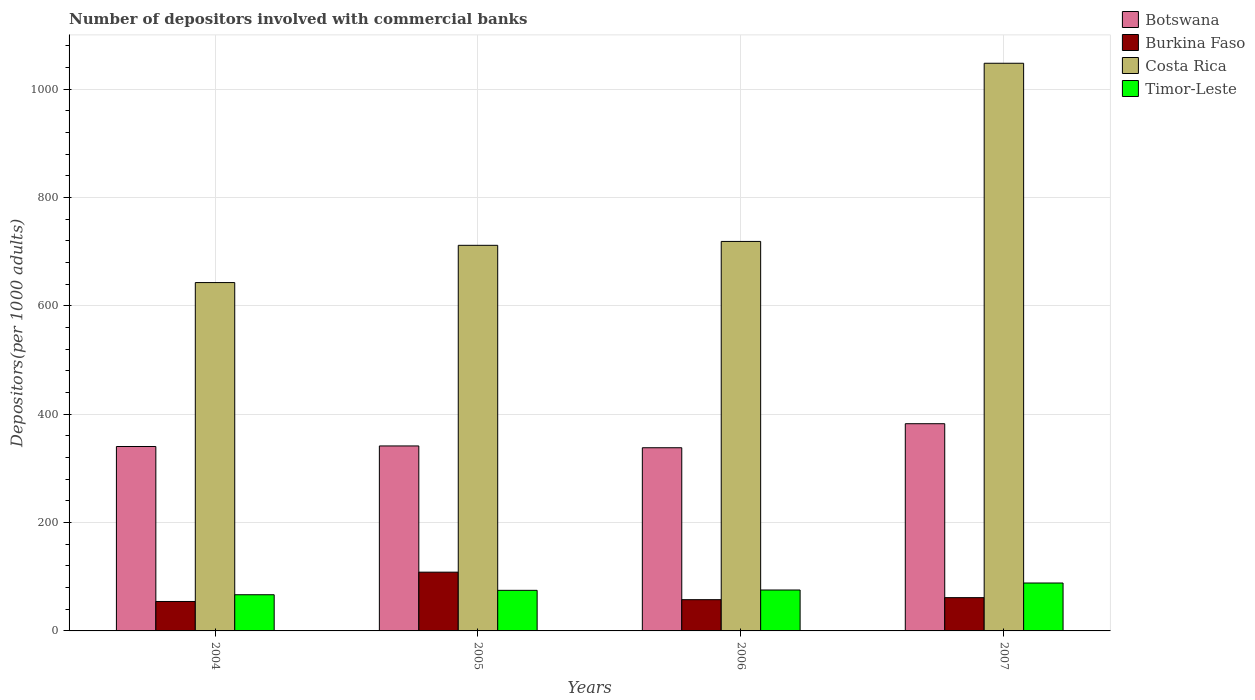How many different coloured bars are there?
Provide a succinct answer. 4. How many groups of bars are there?
Your response must be concise. 4. Are the number of bars per tick equal to the number of legend labels?
Offer a terse response. Yes. Are the number of bars on each tick of the X-axis equal?
Offer a very short reply. Yes. How many bars are there on the 4th tick from the right?
Offer a very short reply. 4. In how many cases, is the number of bars for a given year not equal to the number of legend labels?
Your answer should be compact. 0. What is the number of depositors involved with commercial banks in Costa Rica in 2005?
Ensure brevity in your answer.  711.68. Across all years, what is the maximum number of depositors involved with commercial banks in Timor-Leste?
Your answer should be compact. 88.44. Across all years, what is the minimum number of depositors involved with commercial banks in Botswana?
Ensure brevity in your answer.  338.08. What is the total number of depositors involved with commercial banks in Burkina Faso in the graph?
Offer a terse response. 281.87. What is the difference between the number of depositors involved with commercial banks in Timor-Leste in 2004 and that in 2006?
Your response must be concise. -8.76. What is the difference between the number of depositors involved with commercial banks in Timor-Leste in 2005 and the number of depositors involved with commercial banks in Botswana in 2004?
Offer a terse response. -265.45. What is the average number of depositors involved with commercial banks in Costa Rica per year?
Your response must be concise. 780.3. In the year 2007, what is the difference between the number of depositors involved with commercial banks in Costa Rica and number of depositors involved with commercial banks in Botswana?
Ensure brevity in your answer.  665.28. In how many years, is the number of depositors involved with commercial banks in Timor-Leste greater than 400?
Provide a succinct answer. 0. What is the ratio of the number of depositors involved with commercial banks in Costa Rica in 2004 to that in 2007?
Make the answer very short. 0.61. Is the difference between the number of depositors involved with commercial banks in Costa Rica in 2006 and 2007 greater than the difference between the number of depositors involved with commercial banks in Botswana in 2006 and 2007?
Provide a succinct answer. No. What is the difference between the highest and the second highest number of depositors involved with commercial banks in Burkina Faso?
Your answer should be very brief. 47.04. What is the difference between the highest and the lowest number of depositors involved with commercial banks in Costa Rica?
Your answer should be compact. 404.79. What does the 2nd bar from the left in 2004 represents?
Offer a terse response. Burkina Faso. What does the 4th bar from the right in 2006 represents?
Offer a very short reply. Botswana. Is it the case that in every year, the sum of the number of depositors involved with commercial banks in Timor-Leste and number of depositors involved with commercial banks in Burkina Faso is greater than the number of depositors involved with commercial banks in Botswana?
Keep it short and to the point. No. How many bars are there?
Your answer should be compact. 16. Are the values on the major ticks of Y-axis written in scientific E-notation?
Provide a succinct answer. No. How many legend labels are there?
Offer a terse response. 4. How are the legend labels stacked?
Make the answer very short. Vertical. What is the title of the graph?
Ensure brevity in your answer.  Number of depositors involved with commercial banks. What is the label or title of the X-axis?
Provide a succinct answer. Years. What is the label or title of the Y-axis?
Offer a very short reply. Depositors(per 1000 adults). What is the Depositors(per 1000 adults) in Botswana in 2004?
Keep it short and to the point. 340.37. What is the Depositors(per 1000 adults) in Burkina Faso in 2004?
Provide a short and direct response. 54.35. What is the Depositors(per 1000 adults) of Costa Rica in 2004?
Offer a very short reply. 642.93. What is the Depositors(per 1000 adults) in Timor-Leste in 2004?
Ensure brevity in your answer.  66.76. What is the Depositors(per 1000 adults) of Botswana in 2005?
Offer a very short reply. 341.4. What is the Depositors(per 1000 adults) in Burkina Faso in 2005?
Keep it short and to the point. 108.45. What is the Depositors(per 1000 adults) of Costa Rica in 2005?
Provide a short and direct response. 711.68. What is the Depositors(per 1000 adults) in Timor-Leste in 2005?
Ensure brevity in your answer.  74.92. What is the Depositors(per 1000 adults) in Botswana in 2006?
Offer a very short reply. 338.08. What is the Depositors(per 1000 adults) in Burkina Faso in 2006?
Your answer should be very brief. 57.67. What is the Depositors(per 1000 adults) of Costa Rica in 2006?
Your response must be concise. 718.87. What is the Depositors(per 1000 adults) in Timor-Leste in 2006?
Your answer should be very brief. 75.52. What is the Depositors(per 1000 adults) in Botswana in 2007?
Make the answer very short. 382.43. What is the Depositors(per 1000 adults) in Burkina Faso in 2007?
Keep it short and to the point. 61.41. What is the Depositors(per 1000 adults) in Costa Rica in 2007?
Your answer should be compact. 1047.71. What is the Depositors(per 1000 adults) in Timor-Leste in 2007?
Your answer should be very brief. 88.44. Across all years, what is the maximum Depositors(per 1000 adults) in Botswana?
Make the answer very short. 382.43. Across all years, what is the maximum Depositors(per 1000 adults) of Burkina Faso?
Provide a short and direct response. 108.45. Across all years, what is the maximum Depositors(per 1000 adults) of Costa Rica?
Provide a succinct answer. 1047.71. Across all years, what is the maximum Depositors(per 1000 adults) in Timor-Leste?
Provide a succinct answer. 88.44. Across all years, what is the minimum Depositors(per 1000 adults) in Botswana?
Give a very brief answer. 338.08. Across all years, what is the minimum Depositors(per 1000 adults) of Burkina Faso?
Provide a succinct answer. 54.35. Across all years, what is the minimum Depositors(per 1000 adults) of Costa Rica?
Your answer should be compact. 642.93. Across all years, what is the minimum Depositors(per 1000 adults) in Timor-Leste?
Offer a terse response. 66.76. What is the total Depositors(per 1000 adults) of Botswana in the graph?
Provide a short and direct response. 1402.28. What is the total Depositors(per 1000 adults) in Burkina Faso in the graph?
Your answer should be compact. 281.87. What is the total Depositors(per 1000 adults) in Costa Rica in the graph?
Your answer should be very brief. 3121.18. What is the total Depositors(per 1000 adults) of Timor-Leste in the graph?
Make the answer very short. 305.65. What is the difference between the Depositors(per 1000 adults) in Botswana in 2004 and that in 2005?
Your response must be concise. -1.03. What is the difference between the Depositors(per 1000 adults) in Burkina Faso in 2004 and that in 2005?
Your response must be concise. -54.1. What is the difference between the Depositors(per 1000 adults) of Costa Rica in 2004 and that in 2005?
Your answer should be compact. -68.75. What is the difference between the Depositors(per 1000 adults) of Timor-Leste in 2004 and that in 2005?
Your answer should be compact. -8.16. What is the difference between the Depositors(per 1000 adults) in Botswana in 2004 and that in 2006?
Ensure brevity in your answer.  2.3. What is the difference between the Depositors(per 1000 adults) of Burkina Faso in 2004 and that in 2006?
Keep it short and to the point. -3.32. What is the difference between the Depositors(per 1000 adults) in Costa Rica in 2004 and that in 2006?
Your response must be concise. -75.94. What is the difference between the Depositors(per 1000 adults) of Timor-Leste in 2004 and that in 2006?
Your answer should be very brief. -8.76. What is the difference between the Depositors(per 1000 adults) in Botswana in 2004 and that in 2007?
Provide a succinct answer. -42.06. What is the difference between the Depositors(per 1000 adults) in Burkina Faso in 2004 and that in 2007?
Give a very brief answer. -7.06. What is the difference between the Depositors(per 1000 adults) in Costa Rica in 2004 and that in 2007?
Ensure brevity in your answer.  -404.79. What is the difference between the Depositors(per 1000 adults) in Timor-Leste in 2004 and that in 2007?
Offer a terse response. -21.68. What is the difference between the Depositors(per 1000 adults) in Botswana in 2005 and that in 2006?
Keep it short and to the point. 3.33. What is the difference between the Depositors(per 1000 adults) of Burkina Faso in 2005 and that in 2006?
Provide a short and direct response. 50.78. What is the difference between the Depositors(per 1000 adults) of Costa Rica in 2005 and that in 2006?
Your answer should be compact. -7.19. What is the difference between the Depositors(per 1000 adults) of Timor-Leste in 2005 and that in 2006?
Provide a succinct answer. -0.61. What is the difference between the Depositors(per 1000 adults) of Botswana in 2005 and that in 2007?
Ensure brevity in your answer.  -41.03. What is the difference between the Depositors(per 1000 adults) in Burkina Faso in 2005 and that in 2007?
Keep it short and to the point. 47.04. What is the difference between the Depositors(per 1000 adults) in Costa Rica in 2005 and that in 2007?
Make the answer very short. -336.04. What is the difference between the Depositors(per 1000 adults) in Timor-Leste in 2005 and that in 2007?
Offer a terse response. -13.52. What is the difference between the Depositors(per 1000 adults) of Botswana in 2006 and that in 2007?
Give a very brief answer. -44.36. What is the difference between the Depositors(per 1000 adults) of Burkina Faso in 2006 and that in 2007?
Make the answer very short. -3.74. What is the difference between the Depositors(per 1000 adults) in Costa Rica in 2006 and that in 2007?
Provide a short and direct response. -328.85. What is the difference between the Depositors(per 1000 adults) in Timor-Leste in 2006 and that in 2007?
Give a very brief answer. -12.92. What is the difference between the Depositors(per 1000 adults) of Botswana in 2004 and the Depositors(per 1000 adults) of Burkina Faso in 2005?
Offer a very short reply. 231.92. What is the difference between the Depositors(per 1000 adults) in Botswana in 2004 and the Depositors(per 1000 adults) in Costa Rica in 2005?
Keep it short and to the point. -371.3. What is the difference between the Depositors(per 1000 adults) of Botswana in 2004 and the Depositors(per 1000 adults) of Timor-Leste in 2005?
Ensure brevity in your answer.  265.45. What is the difference between the Depositors(per 1000 adults) in Burkina Faso in 2004 and the Depositors(per 1000 adults) in Costa Rica in 2005?
Provide a succinct answer. -657.33. What is the difference between the Depositors(per 1000 adults) in Burkina Faso in 2004 and the Depositors(per 1000 adults) in Timor-Leste in 2005?
Ensure brevity in your answer.  -20.57. What is the difference between the Depositors(per 1000 adults) of Costa Rica in 2004 and the Depositors(per 1000 adults) of Timor-Leste in 2005?
Your answer should be very brief. 568.01. What is the difference between the Depositors(per 1000 adults) of Botswana in 2004 and the Depositors(per 1000 adults) of Burkina Faso in 2006?
Your answer should be very brief. 282.71. What is the difference between the Depositors(per 1000 adults) in Botswana in 2004 and the Depositors(per 1000 adults) in Costa Rica in 2006?
Offer a very short reply. -378.49. What is the difference between the Depositors(per 1000 adults) in Botswana in 2004 and the Depositors(per 1000 adults) in Timor-Leste in 2006?
Your response must be concise. 264.85. What is the difference between the Depositors(per 1000 adults) of Burkina Faso in 2004 and the Depositors(per 1000 adults) of Costa Rica in 2006?
Provide a succinct answer. -664.52. What is the difference between the Depositors(per 1000 adults) of Burkina Faso in 2004 and the Depositors(per 1000 adults) of Timor-Leste in 2006?
Provide a short and direct response. -21.18. What is the difference between the Depositors(per 1000 adults) in Costa Rica in 2004 and the Depositors(per 1000 adults) in Timor-Leste in 2006?
Offer a terse response. 567.4. What is the difference between the Depositors(per 1000 adults) in Botswana in 2004 and the Depositors(per 1000 adults) in Burkina Faso in 2007?
Ensure brevity in your answer.  278.96. What is the difference between the Depositors(per 1000 adults) of Botswana in 2004 and the Depositors(per 1000 adults) of Costa Rica in 2007?
Provide a succinct answer. -707.34. What is the difference between the Depositors(per 1000 adults) of Botswana in 2004 and the Depositors(per 1000 adults) of Timor-Leste in 2007?
Your answer should be very brief. 251.93. What is the difference between the Depositors(per 1000 adults) in Burkina Faso in 2004 and the Depositors(per 1000 adults) in Costa Rica in 2007?
Offer a terse response. -993.37. What is the difference between the Depositors(per 1000 adults) of Burkina Faso in 2004 and the Depositors(per 1000 adults) of Timor-Leste in 2007?
Provide a short and direct response. -34.1. What is the difference between the Depositors(per 1000 adults) in Costa Rica in 2004 and the Depositors(per 1000 adults) in Timor-Leste in 2007?
Your answer should be very brief. 554.48. What is the difference between the Depositors(per 1000 adults) of Botswana in 2005 and the Depositors(per 1000 adults) of Burkina Faso in 2006?
Your answer should be very brief. 283.74. What is the difference between the Depositors(per 1000 adults) of Botswana in 2005 and the Depositors(per 1000 adults) of Costa Rica in 2006?
Give a very brief answer. -377.46. What is the difference between the Depositors(per 1000 adults) of Botswana in 2005 and the Depositors(per 1000 adults) of Timor-Leste in 2006?
Ensure brevity in your answer.  265.88. What is the difference between the Depositors(per 1000 adults) of Burkina Faso in 2005 and the Depositors(per 1000 adults) of Costa Rica in 2006?
Offer a terse response. -610.42. What is the difference between the Depositors(per 1000 adults) in Burkina Faso in 2005 and the Depositors(per 1000 adults) in Timor-Leste in 2006?
Ensure brevity in your answer.  32.92. What is the difference between the Depositors(per 1000 adults) of Costa Rica in 2005 and the Depositors(per 1000 adults) of Timor-Leste in 2006?
Offer a very short reply. 636.15. What is the difference between the Depositors(per 1000 adults) of Botswana in 2005 and the Depositors(per 1000 adults) of Burkina Faso in 2007?
Ensure brevity in your answer.  279.99. What is the difference between the Depositors(per 1000 adults) of Botswana in 2005 and the Depositors(per 1000 adults) of Costa Rica in 2007?
Offer a very short reply. -706.31. What is the difference between the Depositors(per 1000 adults) in Botswana in 2005 and the Depositors(per 1000 adults) in Timor-Leste in 2007?
Your answer should be compact. 252.96. What is the difference between the Depositors(per 1000 adults) in Burkina Faso in 2005 and the Depositors(per 1000 adults) in Costa Rica in 2007?
Your answer should be compact. -939.27. What is the difference between the Depositors(per 1000 adults) in Burkina Faso in 2005 and the Depositors(per 1000 adults) in Timor-Leste in 2007?
Offer a very short reply. 20. What is the difference between the Depositors(per 1000 adults) of Costa Rica in 2005 and the Depositors(per 1000 adults) of Timor-Leste in 2007?
Your answer should be compact. 623.23. What is the difference between the Depositors(per 1000 adults) of Botswana in 2006 and the Depositors(per 1000 adults) of Burkina Faso in 2007?
Your answer should be compact. 276.67. What is the difference between the Depositors(per 1000 adults) of Botswana in 2006 and the Depositors(per 1000 adults) of Costa Rica in 2007?
Keep it short and to the point. -709.64. What is the difference between the Depositors(per 1000 adults) of Botswana in 2006 and the Depositors(per 1000 adults) of Timor-Leste in 2007?
Offer a very short reply. 249.63. What is the difference between the Depositors(per 1000 adults) in Burkina Faso in 2006 and the Depositors(per 1000 adults) in Costa Rica in 2007?
Make the answer very short. -990.05. What is the difference between the Depositors(per 1000 adults) of Burkina Faso in 2006 and the Depositors(per 1000 adults) of Timor-Leste in 2007?
Offer a terse response. -30.78. What is the difference between the Depositors(per 1000 adults) in Costa Rica in 2006 and the Depositors(per 1000 adults) in Timor-Leste in 2007?
Your answer should be very brief. 630.42. What is the average Depositors(per 1000 adults) in Botswana per year?
Your answer should be very brief. 350.57. What is the average Depositors(per 1000 adults) in Burkina Faso per year?
Provide a succinct answer. 70.47. What is the average Depositors(per 1000 adults) of Costa Rica per year?
Keep it short and to the point. 780.3. What is the average Depositors(per 1000 adults) of Timor-Leste per year?
Offer a very short reply. 76.41. In the year 2004, what is the difference between the Depositors(per 1000 adults) of Botswana and Depositors(per 1000 adults) of Burkina Faso?
Your answer should be very brief. 286.02. In the year 2004, what is the difference between the Depositors(per 1000 adults) in Botswana and Depositors(per 1000 adults) in Costa Rica?
Make the answer very short. -302.55. In the year 2004, what is the difference between the Depositors(per 1000 adults) in Botswana and Depositors(per 1000 adults) in Timor-Leste?
Your answer should be very brief. 273.61. In the year 2004, what is the difference between the Depositors(per 1000 adults) of Burkina Faso and Depositors(per 1000 adults) of Costa Rica?
Offer a terse response. -588.58. In the year 2004, what is the difference between the Depositors(per 1000 adults) of Burkina Faso and Depositors(per 1000 adults) of Timor-Leste?
Provide a succinct answer. -12.41. In the year 2004, what is the difference between the Depositors(per 1000 adults) in Costa Rica and Depositors(per 1000 adults) in Timor-Leste?
Make the answer very short. 576.16. In the year 2005, what is the difference between the Depositors(per 1000 adults) in Botswana and Depositors(per 1000 adults) in Burkina Faso?
Give a very brief answer. 232.95. In the year 2005, what is the difference between the Depositors(per 1000 adults) of Botswana and Depositors(per 1000 adults) of Costa Rica?
Your answer should be very brief. -370.27. In the year 2005, what is the difference between the Depositors(per 1000 adults) in Botswana and Depositors(per 1000 adults) in Timor-Leste?
Make the answer very short. 266.48. In the year 2005, what is the difference between the Depositors(per 1000 adults) in Burkina Faso and Depositors(per 1000 adults) in Costa Rica?
Provide a short and direct response. -603.23. In the year 2005, what is the difference between the Depositors(per 1000 adults) of Burkina Faso and Depositors(per 1000 adults) of Timor-Leste?
Your answer should be very brief. 33.53. In the year 2005, what is the difference between the Depositors(per 1000 adults) of Costa Rica and Depositors(per 1000 adults) of Timor-Leste?
Provide a short and direct response. 636.76. In the year 2006, what is the difference between the Depositors(per 1000 adults) in Botswana and Depositors(per 1000 adults) in Burkina Faso?
Provide a succinct answer. 280.41. In the year 2006, what is the difference between the Depositors(per 1000 adults) in Botswana and Depositors(per 1000 adults) in Costa Rica?
Keep it short and to the point. -380.79. In the year 2006, what is the difference between the Depositors(per 1000 adults) in Botswana and Depositors(per 1000 adults) in Timor-Leste?
Offer a terse response. 262.55. In the year 2006, what is the difference between the Depositors(per 1000 adults) of Burkina Faso and Depositors(per 1000 adults) of Costa Rica?
Make the answer very short. -661.2. In the year 2006, what is the difference between the Depositors(per 1000 adults) of Burkina Faso and Depositors(per 1000 adults) of Timor-Leste?
Ensure brevity in your answer.  -17.86. In the year 2006, what is the difference between the Depositors(per 1000 adults) of Costa Rica and Depositors(per 1000 adults) of Timor-Leste?
Make the answer very short. 643.34. In the year 2007, what is the difference between the Depositors(per 1000 adults) of Botswana and Depositors(per 1000 adults) of Burkina Faso?
Give a very brief answer. 321.02. In the year 2007, what is the difference between the Depositors(per 1000 adults) of Botswana and Depositors(per 1000 adults) of Costa Rica?
Ensure brevity in your answer.  -665.28. In the year 2007, what is the difference between the Depositors(per 1000 adults) of Botswana and Depositors(per 1000 adults) of Timor-Leste?
Provide a short and direct response. 293.99. In the year 2007, what is the difference between the Depositors(per 1000 adults) in Burkina Faso and Depositors(per 1000 adults) in Costa Rica?
Offer a very short reply. -986.31. In the year 2007, what is the difference between the Depositors(per 1000 adults) in Burkina Faso and Depositors(per 1000 adults) in Timor-Leste?
Offer a very short reply. -27.04. In the year 2007, what is the difference between the Depositors(per 1000 adults) in Costa Rica and Depositors(per 1000 adults) in Timor-Leste?
Keep it short and to the point. 959.27. What is the ratio of the Depositors(per 1000 adults) in Botswana in 2004 to that in 2005?
Provide a short and direct response. 1. What is the ratio of the Depositors(per 1000 adults) in Burkina Faso in 2004 to that in 2005?
Keep it short and to the point. 0.5. What is the ratio of the Depositors(per 1000 adults) of Costa Rica in 2004 to that in 2005?
Ensure brevity in your answer.  0.9. What is the ratio of the Depositors(per 1000 adults) of Timor-Leste in 2004 to that in 2005?
Your response must be concise. 0.89. What is the ratio of the Depositors(per 1000 adults) of Botswana in 2004 to that in 2006?
Your response must be concise. 1.01. What is the ratio of the Depositors(per 1000 adults) of Burkina Faso in 2004 to that in 2006?
Your answer should be compact. 0.94. What is the ratio of the Depositors(per 1000 adults) in Costa Rica in 2004 to that in 2006?
Give a very brief answer. 0.89. What is the ratio of the Depositors(per 1000 adults) in Timor-Leste in 2004 to that in 2006?
Make the answer very short. 0.88. What is the ratio of the Depositors(per 1000 adults) of Botswana in 2004 to that in 2007?
Make the answer very short. 0.89. What is the ratio of the Depositors(per 1000 adults) of Burkina Faso in 2004 to that in 2007?
Provide a succinct answer. 0.89. What is the ratio of the Depositors(per 1000 adults) in Costa Rica in 2004 to that in 2007?
Keep it short and to the point. 0.61. What is the ratio of the Depositors(per 1000 adults) of Timor-Leste in 2004 to that in 2007?
Give a very brief answer. 0.75. What is the ratio of the Depositors(per 1000 adults) of Botswana in 2005 to that in 2006?
Give a very brief answer. 1.01. What is the ratio of the Depositors(per 1000 adults) of Burkina Faso in 2005 to that in 2006?
Ensure brevity in your answer.  1.88. What is the ratio of the Depositors(per 1000 adults) of Timor-Leste in 2005 to that in 2006?
Your response must be concise. 0.99. What is the ratio of the Depositors(per 1000 adults) in Botswana in 2005 to that in 2007?
Provide a short and direct response. 0.89. What is the ratio of the Depositors(per 1000 adults) of Burkina Faso in 2005 to that in 2007?
Keep it short and to the point. 1.77. What is the ratio of the Depositors(per 1000 adults) of Costa Rica in 2005 to that in 2007?
Provide a succinct answer. 0.68. What is the ratio of the Depositors(per 1000 adults) in Timor-Leste in 2005 to that in 2007?
Your response must be concise. 0.85. What is the ratio of the Depositors(per 1000 adults) of Botswana in 2006 to that in 2007?
Provide a short and direct response. 0.88. What is the ratio of the Depositors(per 1000 adults) in Burkina Faso in 2006 to that in 2007?
Make the answer very short. 0.94. What is the ratio of the Depositors(per 1000 adults) in Costa Rica in 2006 to that in 2007?
Give a very brief answer. 0.69. What is the ratio of the Depositors(per 1000 adults) in Timor-Leste in 2006 to that in 2007?
Your answer should be very brief. 0.85. What is the difference between the highest and the second highest Depositors(per 1000 adults) of Botswana?
Your answer should be very brief. 41.03. What is the difference between the highest and the second highest Depositors(per 1000 adults) in Burkina Faso?
Provide a succinct answer. 47.04. What is the difference between the highest and the second highest Depositors(per 1000 adults) of Costa Rica?
Provide a succinct answer. 328.85. What is the difference between the highest and the second highest Depositors(per 1000 adults) of Timor-Leste?
Ensure brevity in your answer.  12.92. What is the difference between the highest and the lowest Depositors(per 1000 adults) of Botswana?
Ensure brevity in your answer.  44.36. What is the difference between the highest and the lowest Depositors(per 1000 adults) in Burkina Faso?
Provide a succinct answer. 54.1. What is the difference between the highest and the lowest Depositors(per 1000 adults) of Costa Rica?
Provide a succinct answer. 404.79. What is the difference between the highest and the lowest Depositors(per 1000 adults) of Timor-Leste?
Make the answer very short. 21.68. 